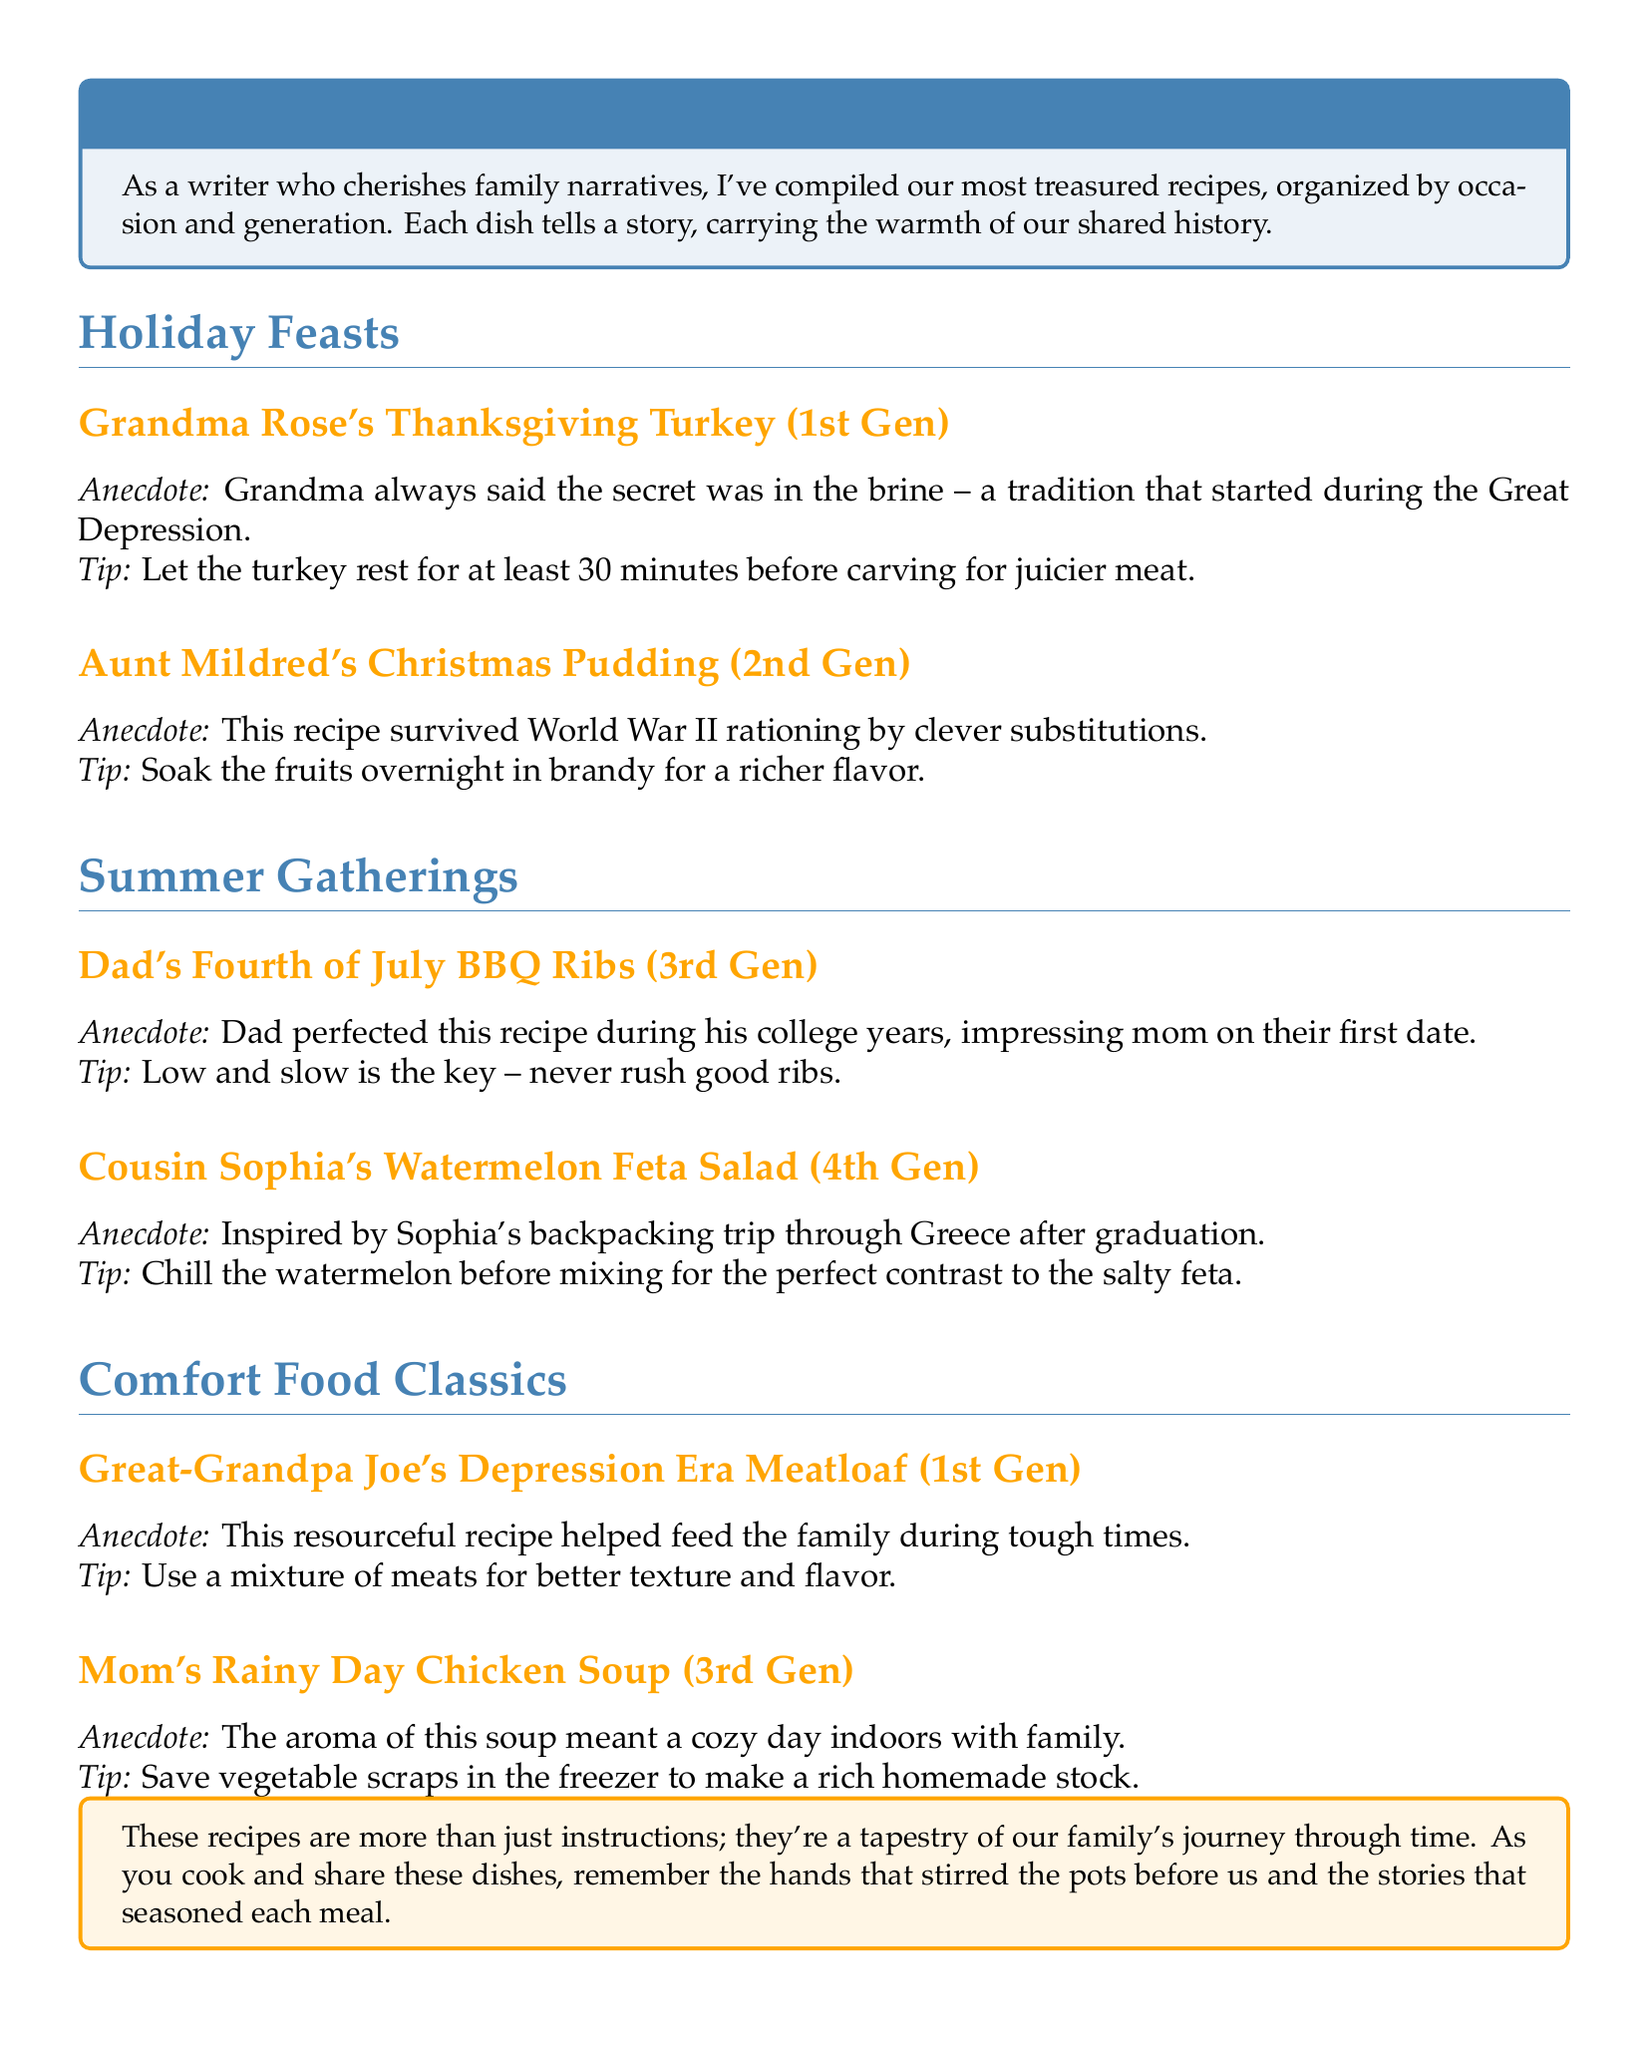What is the title of the document? The title appears in the tcolorbox at the beginning of the document, which introduces the theme of the catalog.
Answer: Our Family's Culinary Legacy: A Generational Recipe Catalog Who created the Thanksgiving Turkey recipe? The recipe is authored by a family member noted in the section header of the Thanksgiving recipes.
Answer: Grandma Rose What occasion is Aunt Mildred's recipe associated with? The occasion is specified in the section header where the recipe is located.
Answer: Christmas Which generation does Dad's BBQ Ribs recipe belong to? The generation is indicated in the subheading under the recipe title.
Answer: 3rd Gen What is a cooking tip for Grandma Rose's turkey? The cooking tip is included in the description of the recipe under the cooking instructions.
Answer: Let the turkey rest for at least 30 minutes How did Aunt Mildred modify her recipe during World War II? The anecdote provides context on how she adapted the recipe amid food shortages.
Answer: By clever substitutions What inspired Cousin Sophia's Watermelon Feta Salad? This question requires connecting the anecdote with the recipe to understand its background.
Answer: Backpacking trip through Greece What does the document describe as a key characteristic of good ribs? The informative statement is provided in a dedicated cooking tip.
Answer: Low and slow 